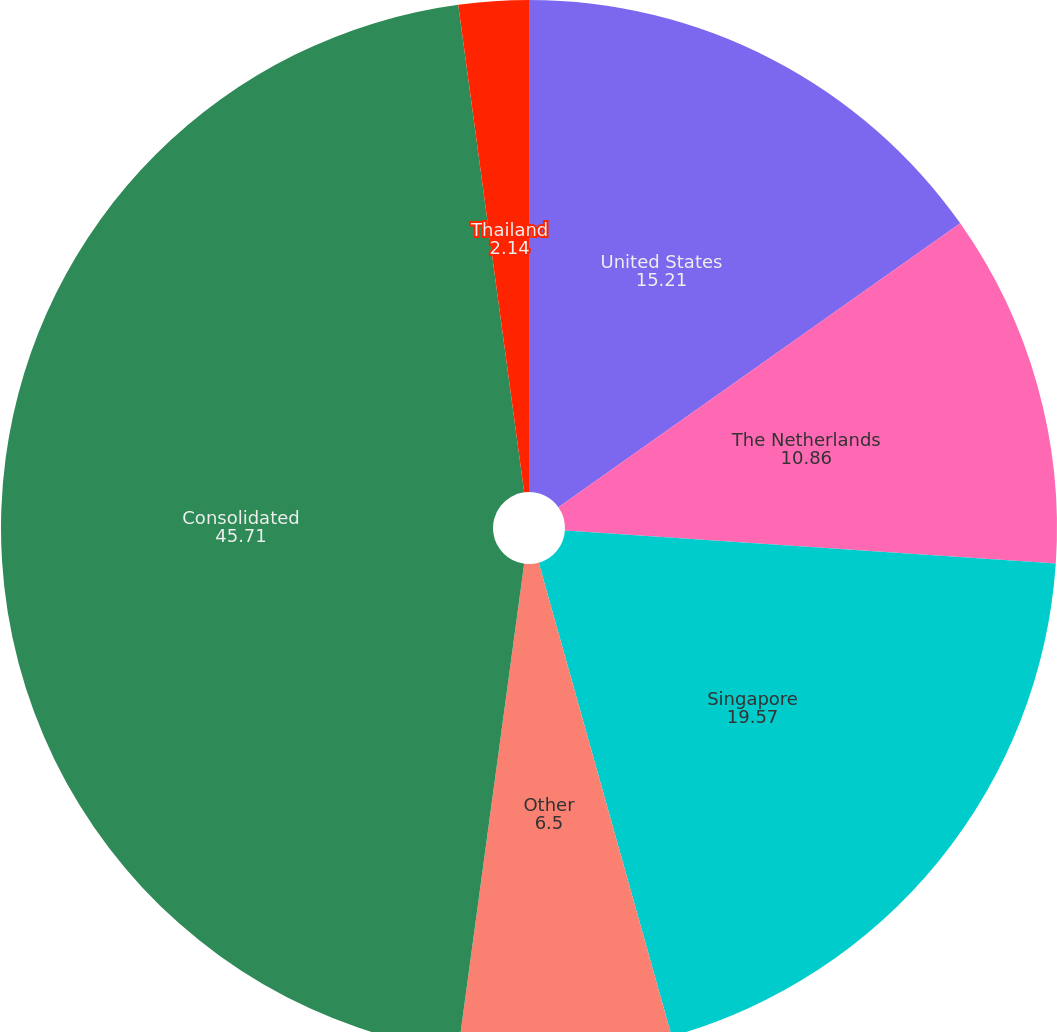<chart> <loc_0><loc_0><loc_500><loc_500><pie_chart><fcel>United States<fcel>The Netherlands<fcel>Singapore<fcel>Other<fcel>Consolidated<fcel>Thailand<nl><fcel>15.21%<fcel>10.86%<fcel>19.57%<fcel>6.5%<fcel>45.71%<fcel>2.14%<nl></chart> 